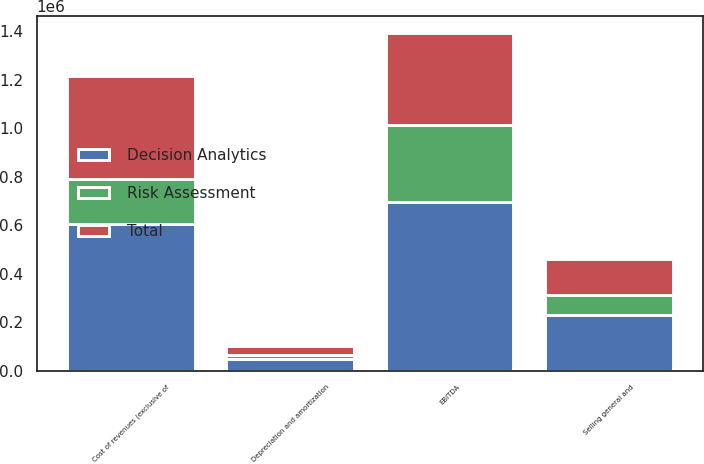Convert chart. <chart><loc_0><loc_0><loc_500><loc_500><stacked_bar_chart><ecel><fcel>Cost of revenues (exclusive of<fcel>Selling general and<fcel>EBITDA<fcel>Depreciation and amortization<nl><fcel>Total<fcel>424746<fcel>150413<fcel>379655<fcel>37093<nl><fcel>Risk Assessment<fcel>182428<fcel>80946<fcel>316260<fcel>13531<nl><fcel>Decision Analytics<fcel>607174<fcel>231359<fcel>695915<fcel>50624<nl></chart> 